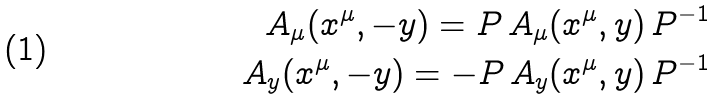Convert formula to latex. <formula><loc_0><loc_0><loc_500><loc_500>A _ { \mu } ( x ^ { \mu } , - y ) = P \, A _ { \mu } ( x ^ { \mu } , y ) \, P ^ { - 1 } \\ A _ { y } ( x ^ { \mu } , - y ) = - P \, A _ { y } ( x ^ { \mu } , y ) \, P ^ { - 1 }</formula> 